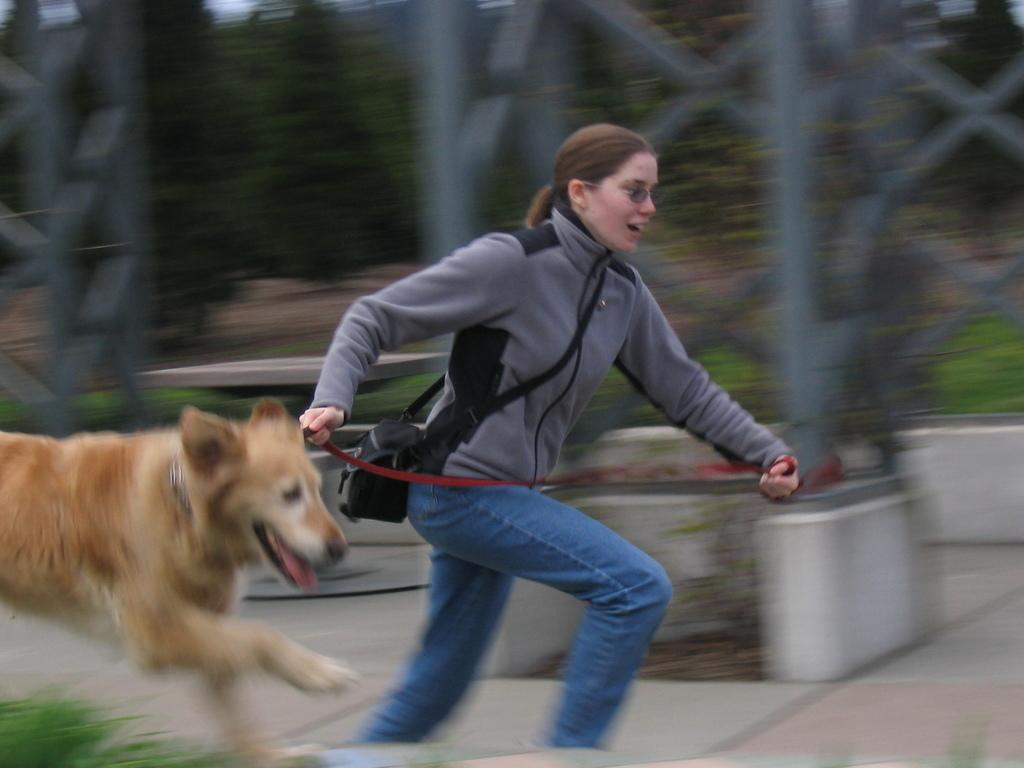Where was the image taken? The image was taken outdoors. Who is present in the image? There are women and a dog in the image. What are the women and the dog doing in the image? The women and the dog are running on the floor. What can be seen in the background of the image? There is a tower and trees visible in the background of the image. What type of needle can be seen in the image? There is no needle present in the image. How does the dog's kick affect the acoustics in the image? There is no mention of the dog kicking anything in the image, and acoustics are not relevant to the visual content of the image. 